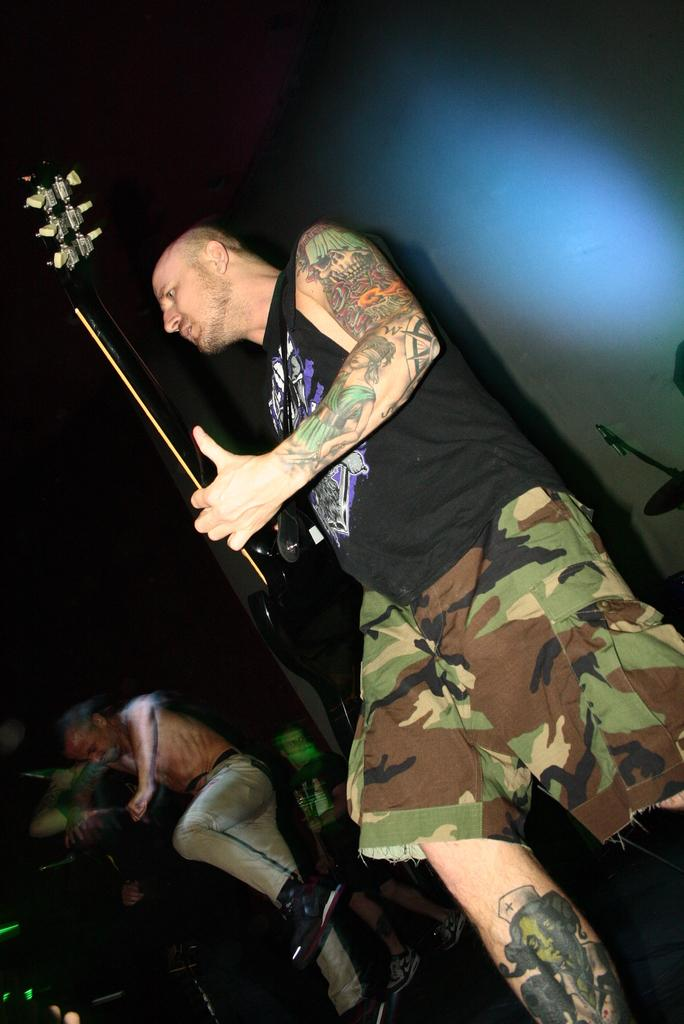Who is the main subject in the image? There is a man in the image. What is the man wearing? The man is wearing a black t-shirt. What is the man doing in the image? The man is playing a guitar. Are there any other people in the image? Yes, there are people standing near the man. What verse is the man reciting in the image? There is no indication in the image that the man is reciting a verse; he is playing a guitar. Is the man holding a baseball bat in the image? There is no baseball bat present in the image; the man is playing a guitar. 